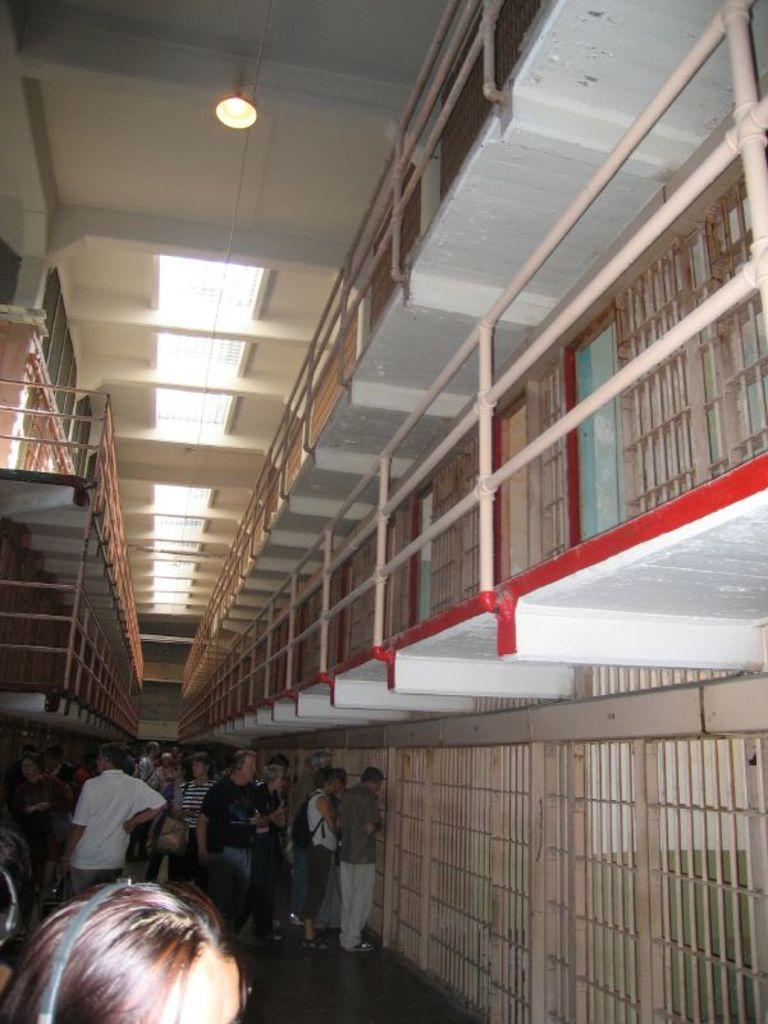What are the people in the image doing? The people in the image are walking. On what surface are the people walking? The people are walking on the floor. What can be seen in the image besides the people walking? There are grills and steel railing present in the image. What is visible in the background of the image? There is a glass ceiling and lights visible in the background. How many bikes are being approved by the bells in the image? There are no bikes or bells present in the image. 